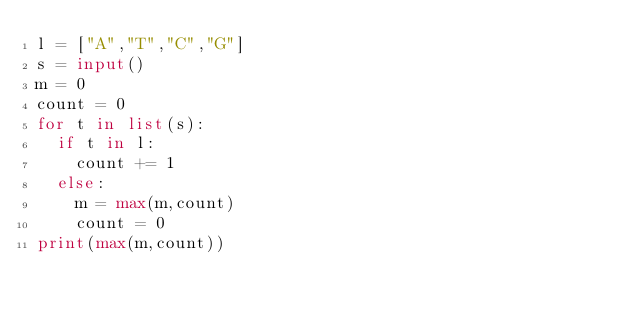Convert code to text. <code><loc_0><loc_0><loc_500><loc_500><_Python_>l = ["A","T","C","G"]
s = input()
m = 0
count = 0
for t in list(s):
  if t in l:
    count += 1
  else:
    m = max(m,count)
    count = 0
print(max(m,count)) 

</code> 